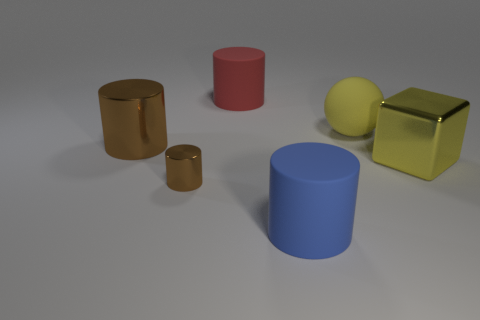Subtract all big blue rubber cylinders. How many cylinders are left? 3 Add 3 yellow metallic things. How many objects exist? 9 Subtract all blue cylinders. How many cylinders are left? 3 Subtract all balls. How many objects are left? 5 Subtract all purple cylinders. Subtract all gray balls. How many cylinders are left? 4 Subtract all red cylinders. How many blue blocks are left? 0 Subtract all big blue rubber objects. Subtract all large blue cylinders. How many objects are left? 4 Add 3 blue rubber things. How many blue rubber things are left? 4 Add 2 shiny blocks. How many shiny blocks exist? 3 Subtract 0 purple cubes. How many objects are left? 6 